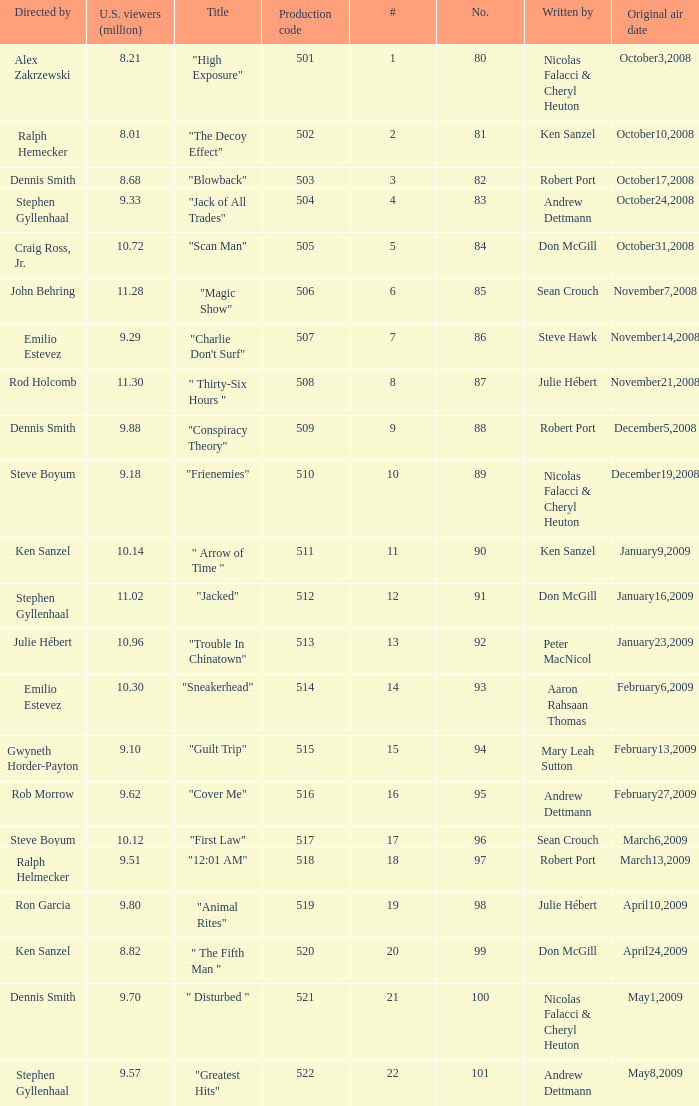Who wrote the episode with the production code 519? Julie Hébert. 